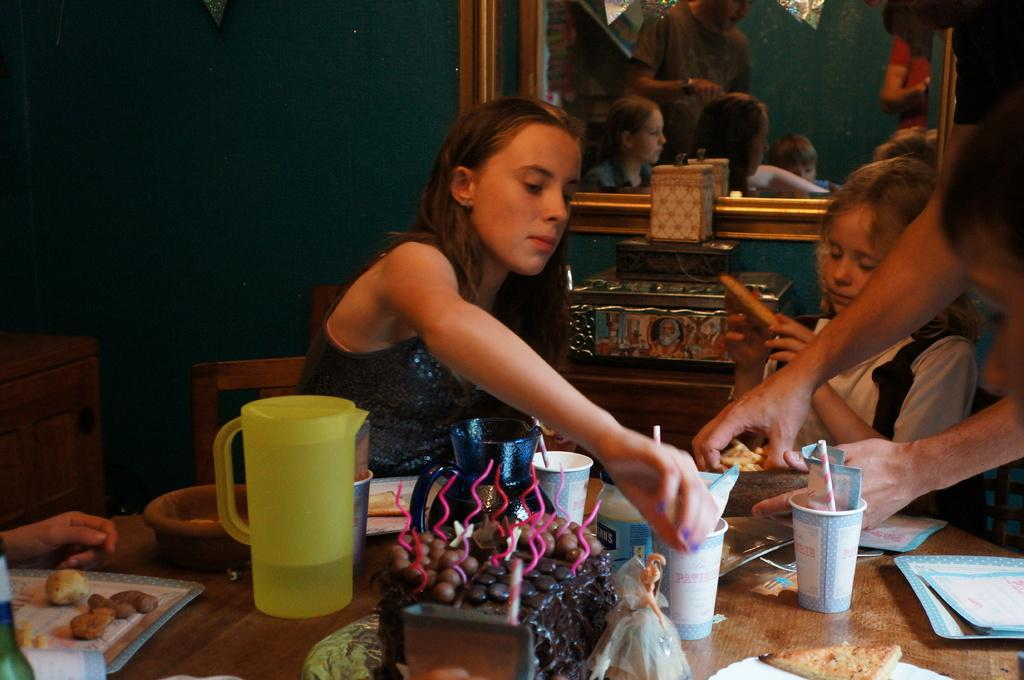Who or what is present in the image? There are people in the image. What are the people doing or where are they located? The people are in front of a table. What can be seen on the table? There are multiple objects on the table. What is visible in the background of the image? There is a wall and a mirror in the background of the image. What type of clover is growing on the table in the image? There is no clover present on the table in the image. What is being served for dinner in the image? The image does not show any dinner being served; it only shows people in front of a table with multiple objects on it. 